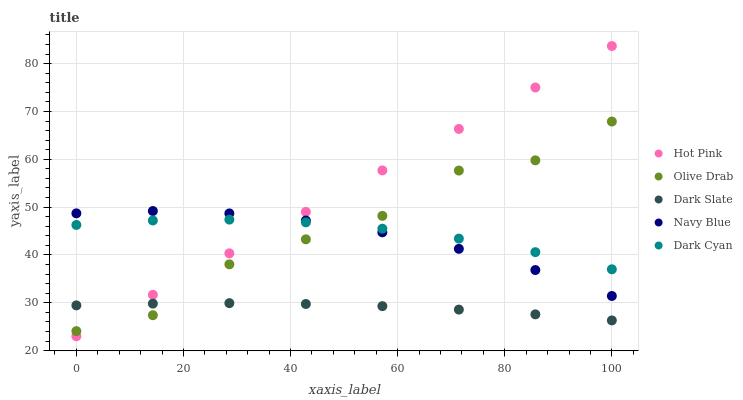Does Dark Slate have the minimum area under the curve?
Answer yes or no. Yes. Does Hot Pink have the maximum area under the curve?
Answer yes or no. Yes. Does Hot Pink have the minimum area under the curve?
Answer yes or no. No. Does Dark Slate have the maximum area under the curve?
Answer yes or no. No. Is Hot Pink the smoothest?
Answer yes or no. Yes. Is Olive Drab the roughest?
Answer yes or no. Yes. Is Dark Slate the smoothest?
Answer yes or no. No. Is Dark Slate the roughest?
Answer yes or no. No. Does Hot Pink have the lowest value?
Answer yes or no. Yes. Does Dark Slate have the lowest value?
Answer yes or no. No. Does Hot Pink have the highest value?
Answer yes or no. Yes. Does Dark Slate have the highest value?
Answer yes or no. No. Is Dark Slate less than Navy Blue?
Answer yes or no. Yes. Is Navy Blue greater than Dark Slate?
Answer yes or no. Yes. Does Navy Blue intersect Olive Drab?
Answer yes or no. Yes. Is Navy Blue less than Olive Drab?
Answer yes or no. No. Is Navy Blue greater than Olive Drab?
Answer yes or no. No. Does Dark Slate intersect Navy Blue?
Answer yes or no. No. 